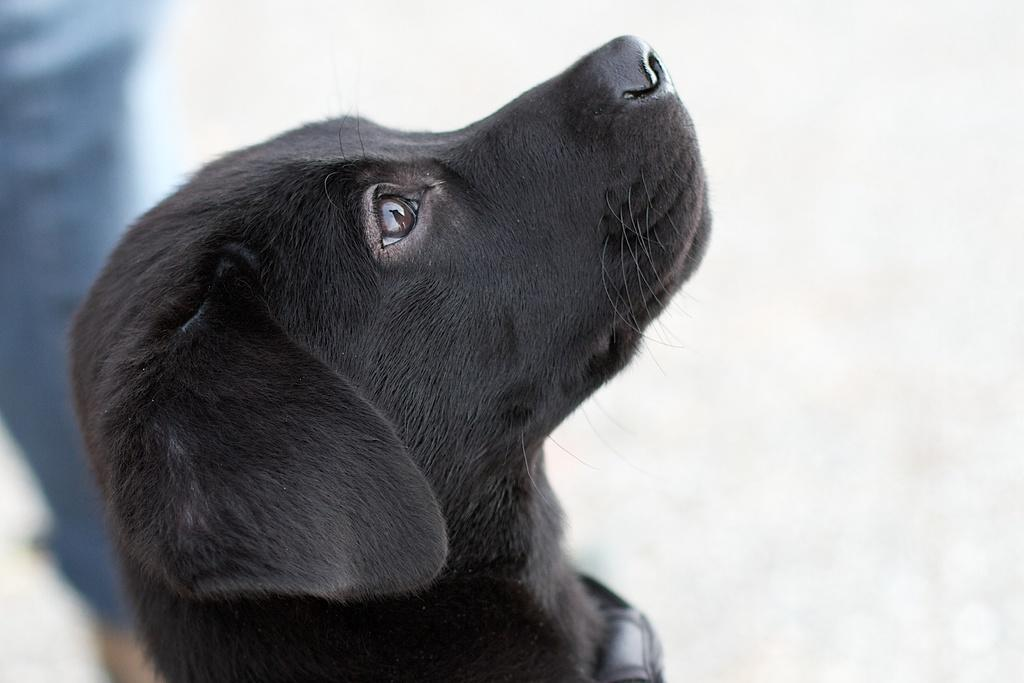What type of animal is in the image? There is a black dog in the image. How would you describe the background of the image? The background of the image has a blurred view. What color can be seen in the image besides the black dog? There is a blue color visible in the image. What type of spot can be seen on the nation in the image? There is no spot or nation present in the image; it features a black dog with a blurred background and a visible blue color. 